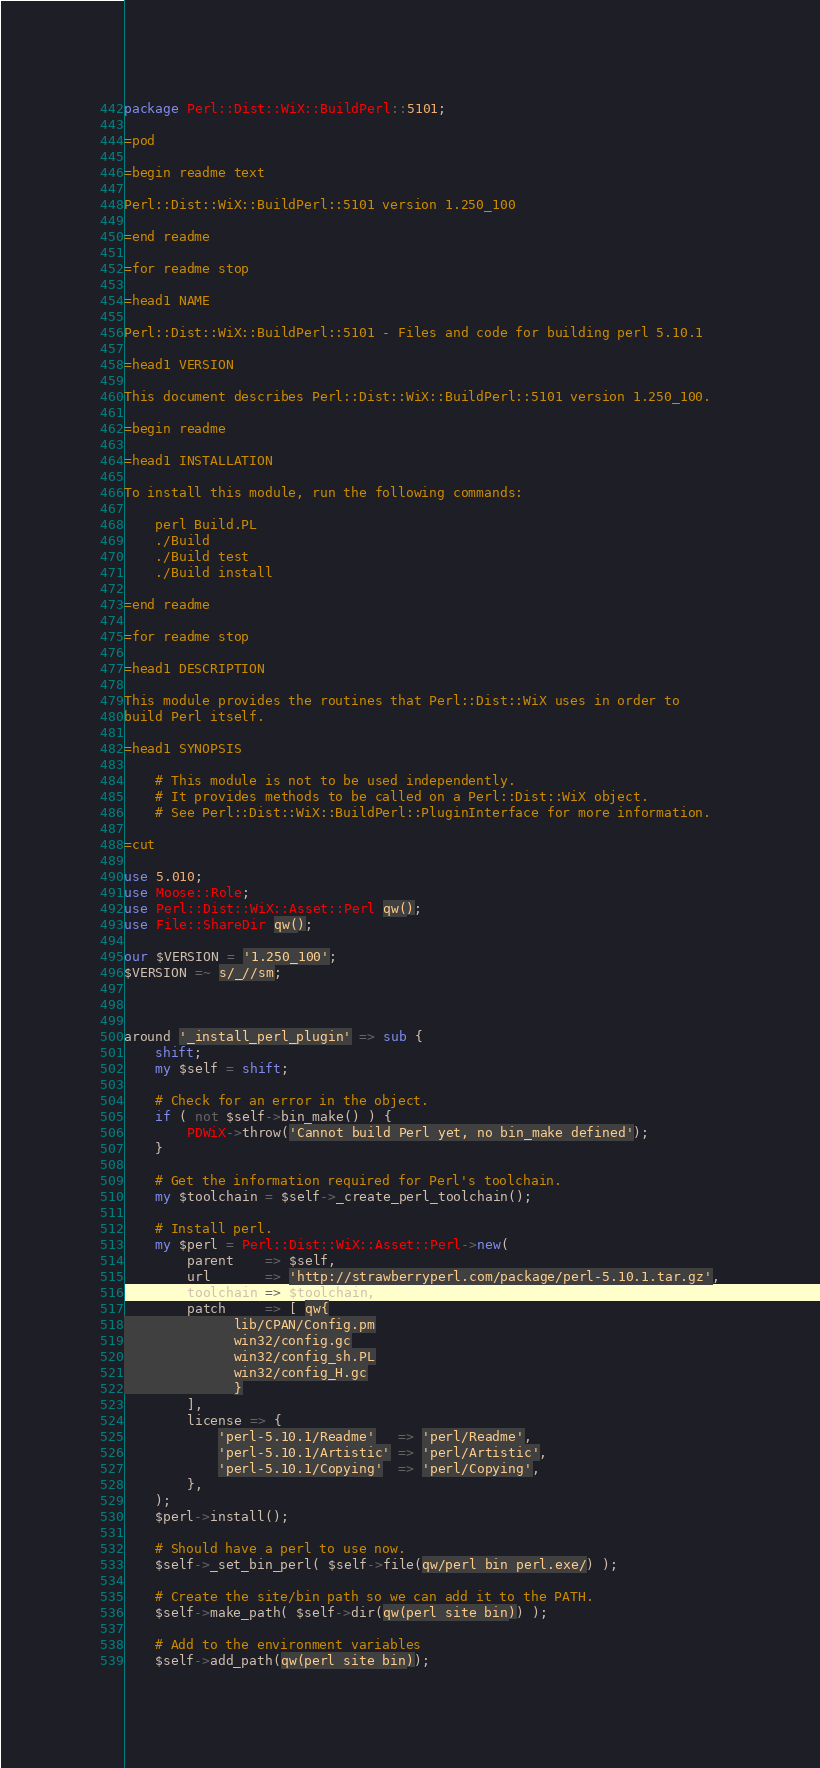Convert code to text. <code><loc_0><loc_0><loc_500><loc_500><_Perl_>package Perl::Dist::WiX::BuildPerl::5101;

=pod

=begin readme text

Perl::Dist::WiX::BuildPerl::5101 version 1.250_100

=end readme

=for readme stop

=head1 NAME

Perl::Dist::WiX::BuildPerl::5101 - Files and code for building perl 5.10.1

=head1 VERSION

This document describes Perl::Dist::WiX::BuildPerl::5101 version 1.250_100.

=begin readme

=head1 INSTALLATION

To install this module, run the following commands:

	perl Build.PL
	./Build
	./Build test
	./Build install

=end readme

=for readme stop

=head1 DESCRIPTION

This module provides the routines that Perl::Dist::WiX uses in order to
build Perl itself.  

=head1 SYNOPSIS

	# This module is not to be used independently.
	# It provides methods to be called on a Perl::Dist::WiX object.
	# See Perl::Dist::WiX::BuildPerl::PluginInterface for more information.

=cut

use 5.010;
use Moose::Role;
use Perl::Dist::WiX::Asset::Perl qw();
use File::ShareDir qw();

our $VERSION = '1.250_100';
$VERSION =~ s/_//sm;



around '_install_perl_plugin' => sub {
	shift;
	my $self = shift;

	# Check for an error in the object.
	if ( not $self->bin_make() ) {
		PDWiX->throw('Cannot build Perl yet, no bin_make defined');
	}

	# Get the information required for Perl's toolchain.
	my $toolchain = $self->_create_perl_toolchain();

	# Install perl.
	my $perl = Perl::Dist::WiX::Asset::Perl->new(
		parent    => $self,
		url       => 'http://strawberryperl.com/package/perl-5.10.1.tar.gz',
		toolchain => $toolchain,
		patch     => [ qw{
			  lib/CPAN/Config.pm
			  win32/config.gc
			  win32/config_sh.PL
			  win32/config_H.gc
			  }
		],
		license => {
			'perl-5.10.1/Readme'   => 'perl/Readme',
			'perl-5.10.1/Artistic' => 'perl/Artistic',
			'perl-5.10.1/Copying'  => 'perl/Copying',
		},
	);
	$perl->install();

	# Should have a perl to use now.
	$self->_set_bin_perl( $self->file(qw/perl bin perl.exe/) );

	# Create the site/bin path so we can add it to the PATH.
	$self->make_path( $self->dir(qw(perl site bin)) );

	# Add to the environment variables
	$self->add_path(qw(perl site bin));</code> 